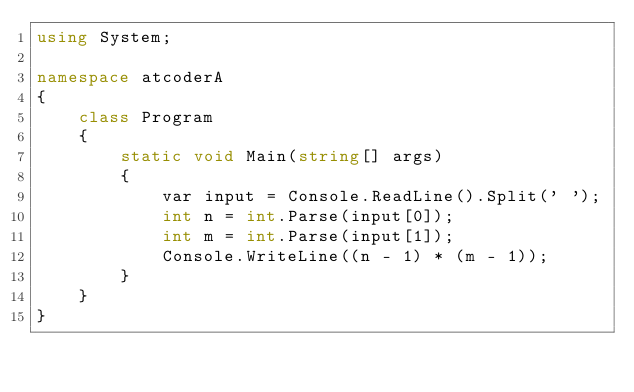<code> <loc_0><loc_0><loc_500><loc_500><_C#_>using System;

namespace atcoderA
{
    class Program
    {
        static void Main(string[] args)
        {
            var input = Console.ReadLine().Split(' ');
            int n = int.Parse(input[0]);
            int m = int.Parse(input[1]);
            Console.WriteLine((n - 1) * (m - 1));
        }
    }
}</code> 